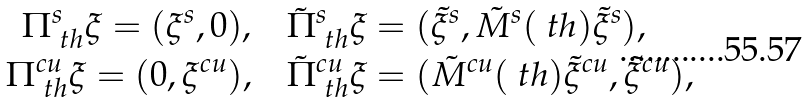Convert formula to latex. <formula><loc_0><loc_0><loc_500><loc_500>\Pi ^ { s } _ { \ t h } \xi = ( \xi ^ { s } , 0 ) , & \quad \tilde { \Pi } ^ { s } _ { \ t h } \xi = ( \tilde { \xi } ^ { s } , \tilde { M } ^ { s } ( \ t h ) \tilde { \xi } ^ { s } ) , \\ \Pi ^ { c u } _ { \ t h } \xi = ( 0 , \xi ^ { c u } ) , & \quad \tilde { \Pi } ^ { c u } _ { \ t h } \xi = ( \tilde { M } ^ { c u } ( \ t h ) \tilde { \xi } ^ { c u } , \tilde { \xi } ^ { c u } ) ,</formula> 